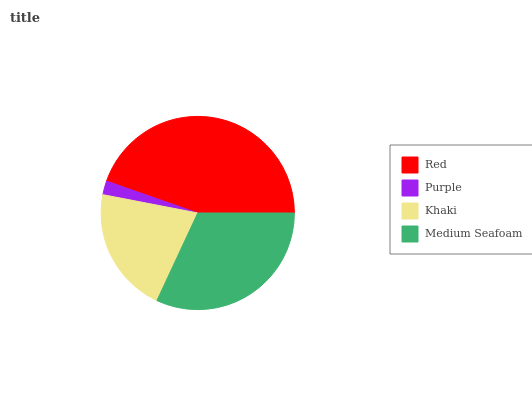Is Purple the minimum?
Answer yes or no. Yes. Is Red the maximum?
Answer yes or no. Yes. Is Khaki the minimum?
Answer yes or no. No. Is Khaki the maximum?
Answer yes or no. No. Is Khaki greater than Purple?
Answer yes or no. Yes. Is Purple less than Khaki?
Answer yes or no. Yes. Is Purple greater than Khaki?
Answer yes or no. No. Is Khaki less than Purple?
Answer yes or no. No. Is Medium Seafoam the high median?
Answer yes or no. Yes. Is Khaki the low median?
Answer yes or no. Yes. Is Khaki the high median?
Answer yes or no. No. Is Red the low median?
Answer yes or no. No. 